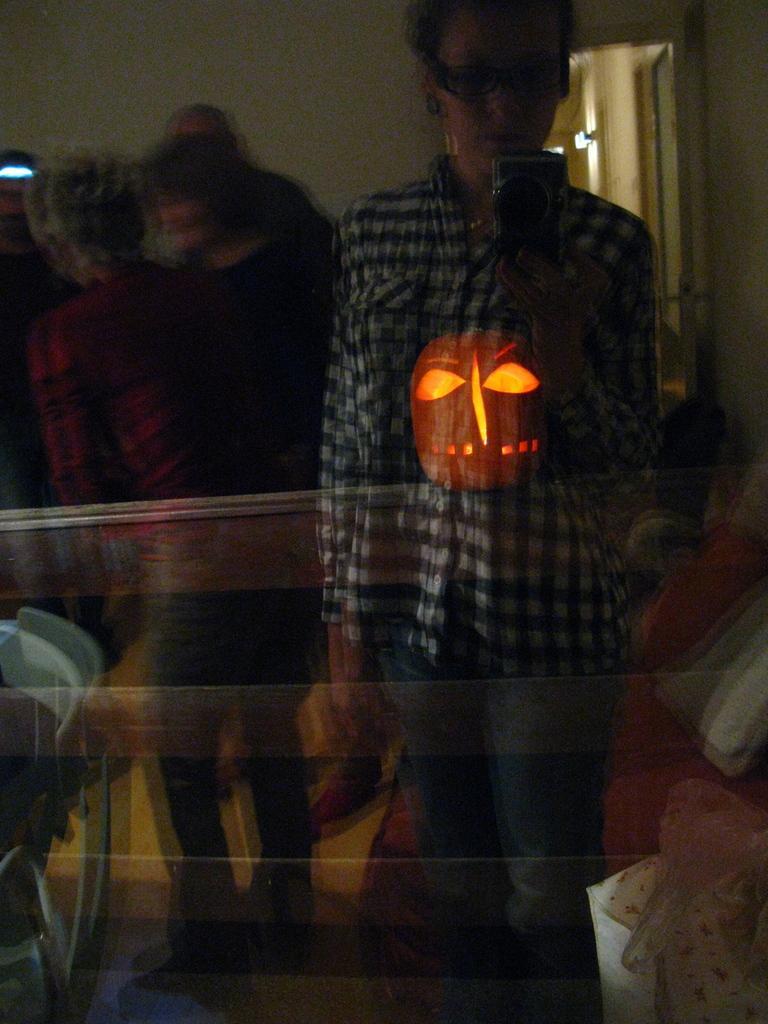How would you summarize this image in a sentence or two? In the foreground of this image, there is a glass. Inside it, there is a pumpkin on an object. In the reflection, there are few people standing and a woman is standing and holding a camera and also we can see the wall, door, couch, pillows and few objects. 